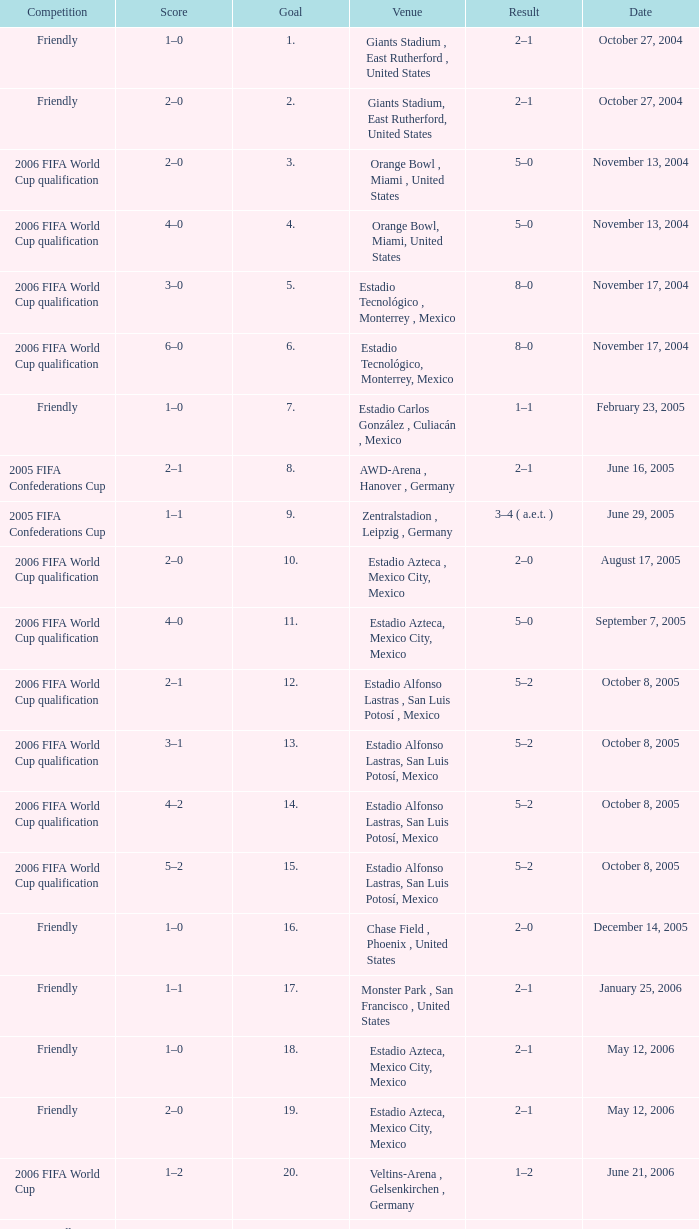Which Result has a Score of 1–0, and a Goal of 16? 2–0. 